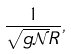<formula> <loc_0><loc_0><loc_500><loc_500>\frac { 1 } { \sqrt { g \mathcal { N } } R } ,</formula> 